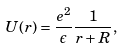<formula> <loc_0><loc_0><loc_500><loc_500>U ( r ) = \frac { e ^ { 2 } } { \epsilon } \frac { 1 } { r + R } ,</formula> 